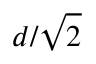Convert formula to latex. <formula><loc_0><loc_0><loc_500><loc_500>d / \sqrt { 2 }</formula> 